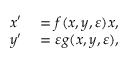<formula> <loc_0><loc_0><loc_500><loc_500>\begin{array} { r l } { x ^ { \prime } } & = f ( x , y , \varepsilon ) x , } \\ { y ^ { \prime } } & = \varepsilon g ( x , y , \varepsilon ) , } \end{array}</formula> 